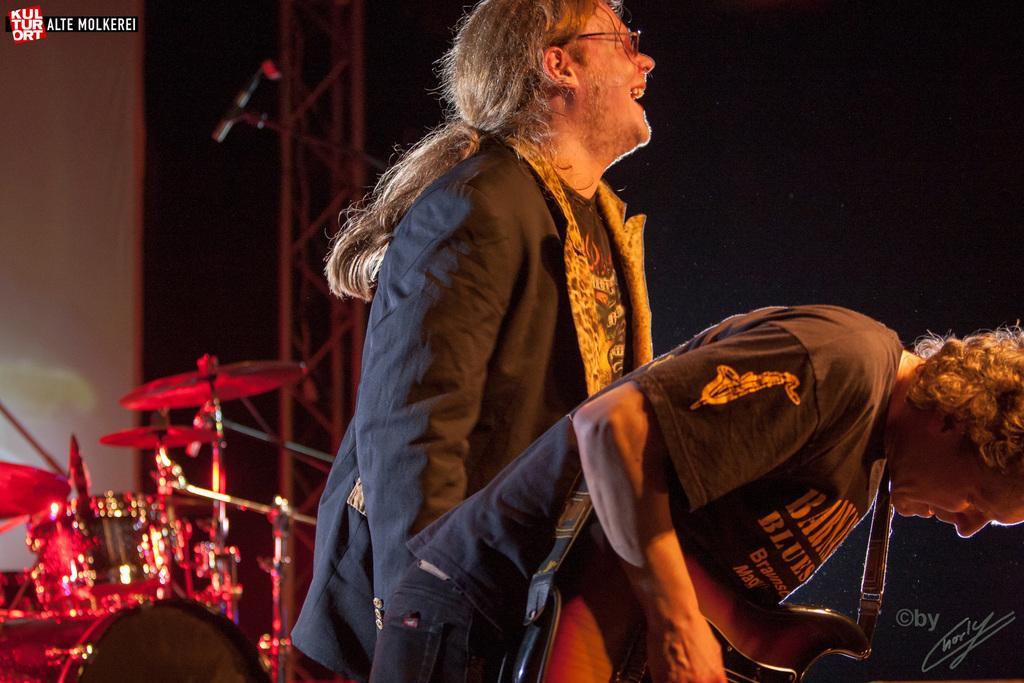How would you summarize this image in a sentence or two? There are two persons. In the front a person is playing a guitar and behind person is smiling and wearing a spectacles. In the background there is a drums. 